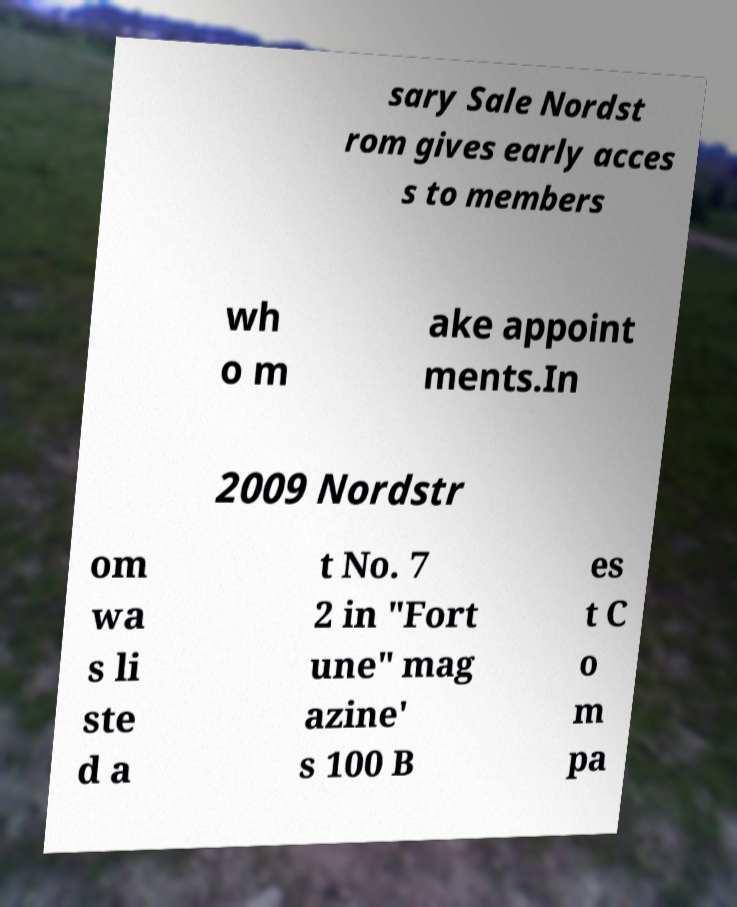Please identify and transcribe the text found in this image. sary Sale Nordst rom gives early acces s to members wh o m ake appoint ments.In 2009 Nordstr om wa s li ste d a t No. 7 2 in "Fort une" mag azine' s 100 B es t C o m pa 